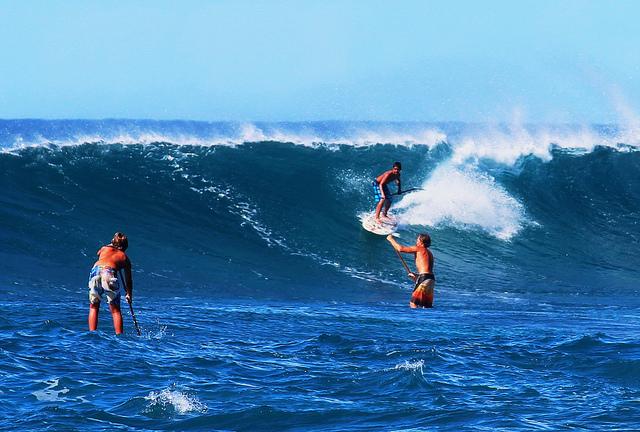How many people in the water?
Write a very short answer. 3. Are there more surfers than paddleboarders in the picture?
Give a very brief answer. No. How much dry land is shown?
Be succinct. 0. Is he going for a swim?
Short answer required. Yes. 